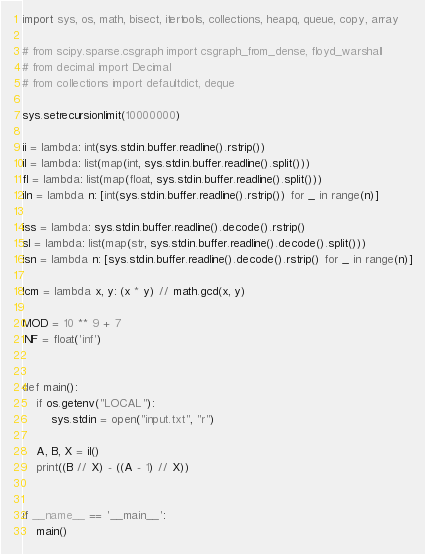Convert code to text. <code><loc_0><loc_0><loc_500><loc_500><_Python_>import sys, os, math, bisect, itertools, collections, heapq, queue, copy, array

# from scipy.sparse.csgraph import csgraph_from_dense, floyd_warshall
# from decimal import Decimal
# from collections import defaultdict, deque

sys.setrecursionlimit(10000000)

ii = lambda: int(sys.stdin.buffer.readline().rstrip())
il = lambda: list(map(int, sys.stdin.buffer.readline().split()))
fl = lambda: list(map(float, sys.stdin.buffer.readline().split()))
iln = lambda n: [int(sys.stdin.buffer.readline().rstrip()) for _ in range(n)]

iss = lambda: sys.stdin.buffer.readline().decode().rstrip()
sl = lambda: list(map(str, sys.stdin.buffer.readline().decode().split()))
isn = lambda n: [sys.stdin.buffer.readline().decode().rstrip() for _ in range(n)]

lcm = lambda x, y: (x * y) // math.gcd(x, y)

MOD = 10 ** 9 + 7
INF = float('inf')


def main():
    if os.getenv("LOCAL"):
        sys.stdin = open("input.txt", "r")

    A, B, X = il()
    print((B // X) - ((A - 1) // X))


if __name__ == '__main__':
    main()
</code> 